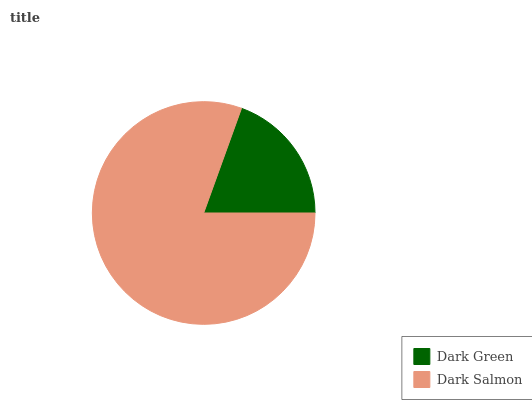Is Dark Green the minimum?
Answer yes or no. Yes. Is Dark Salmon the maximum?
Answer yes or no. Yes. Is Dark Salmon the minimum?
Answer yes or no. No. Is Dark Salmon greater than Dark Green?
Answer yes or no. Yes. Is Dark Green less than Dark Salmon?
Answer yes or no. Yes. Is Dark Green greater than Dark Salmon?
Answer yes or no. No. Is Dark Salmon less than Dark Green?
Answer yes or no. No. Is Dark Salmon the high median?
Answer yes or no. Yes. Is Dark Green the low median?
Answer yes or no. Yes. Is Dark Green the high median?
Answer yes or no. No. Is Dark Salmon the low median?
Answer yes or no. No. 